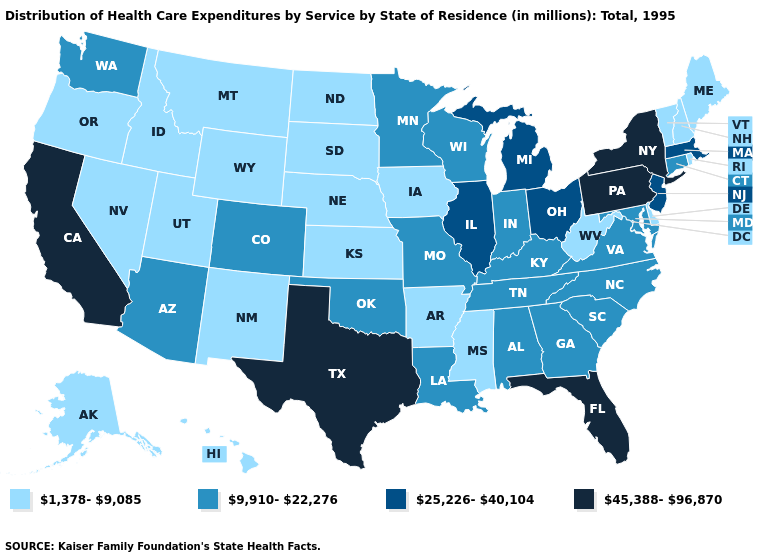Does New York have the highest value in the USA?
Answer briefly. Yes. What is the value of Massachusetts?
Quick response, please. 25,226-40,104. Name the states that have a value in the range 45,388-96,870?
Be succinct. California, Florida, New York, Pennsylvania, Texas. What is the highest value in states that border Colorado?
Give a very brief answer. 9,910-22,276. Name the states that have a value in the range 1,378-9,085?
Write a very short answer. Alaska, Arkansas, Delaware, Hawaii, Idaho, Iowa, Kansas, Maine, Mississippi, Montana, Nebraska, Nevada, New Hampshire, New Mexico, North Dakota, Oregon, Rhode Island, South Dakota, Utah, Vermont, West Virginia, Wyoming. Does Texas have the highest value in the USA?
Concise answer only. Yes. How many symbols are there in the legend?
Quick response, please. 4. What is the lowest value in states that border Arizona?
Short answer required. 1,378-9,085. Does Washington have the lowest value in the USA?
Be succinct. No. Name the states that have a value in the range 1,378-9,085?
Short answer required. Alaska, Arkansas, Delaware, Hawaii, Idaho, Iowa, Kansas, Maine, Mississippi, Montana, Nebraska, Nevada, New Hampshire, New Mexico, North Dakota, Oregon, Rhode Island, South Dakota, Utah, Vermont, West Virginia, Wyoming. Which states have the highest value in the USA?
Concise answer only. California, Florida, New York, Pennsylvania, Texas. Name the states that have a value in the range 1,378-9,085?
Give a very brief answer. Alaska, Arkansas, Delaware, Hawaii, Idaho, Iowa, Kansas, Maine, Mississippi, Montana, Nebraska, Nevada, New Hampshire, New Mexico, North Dakota, Oregon, Rhode Island, South Dakota, Utah, Vermont, West Virginia, Wyoming. Does Alabama have the highest value in the South?
Be succinct. No. Among the states that border Maine , which have the lowest value?
Answer briefly. New Hampshire. What is the value of Kansas?
Be succinct. 1,378-9,085. 